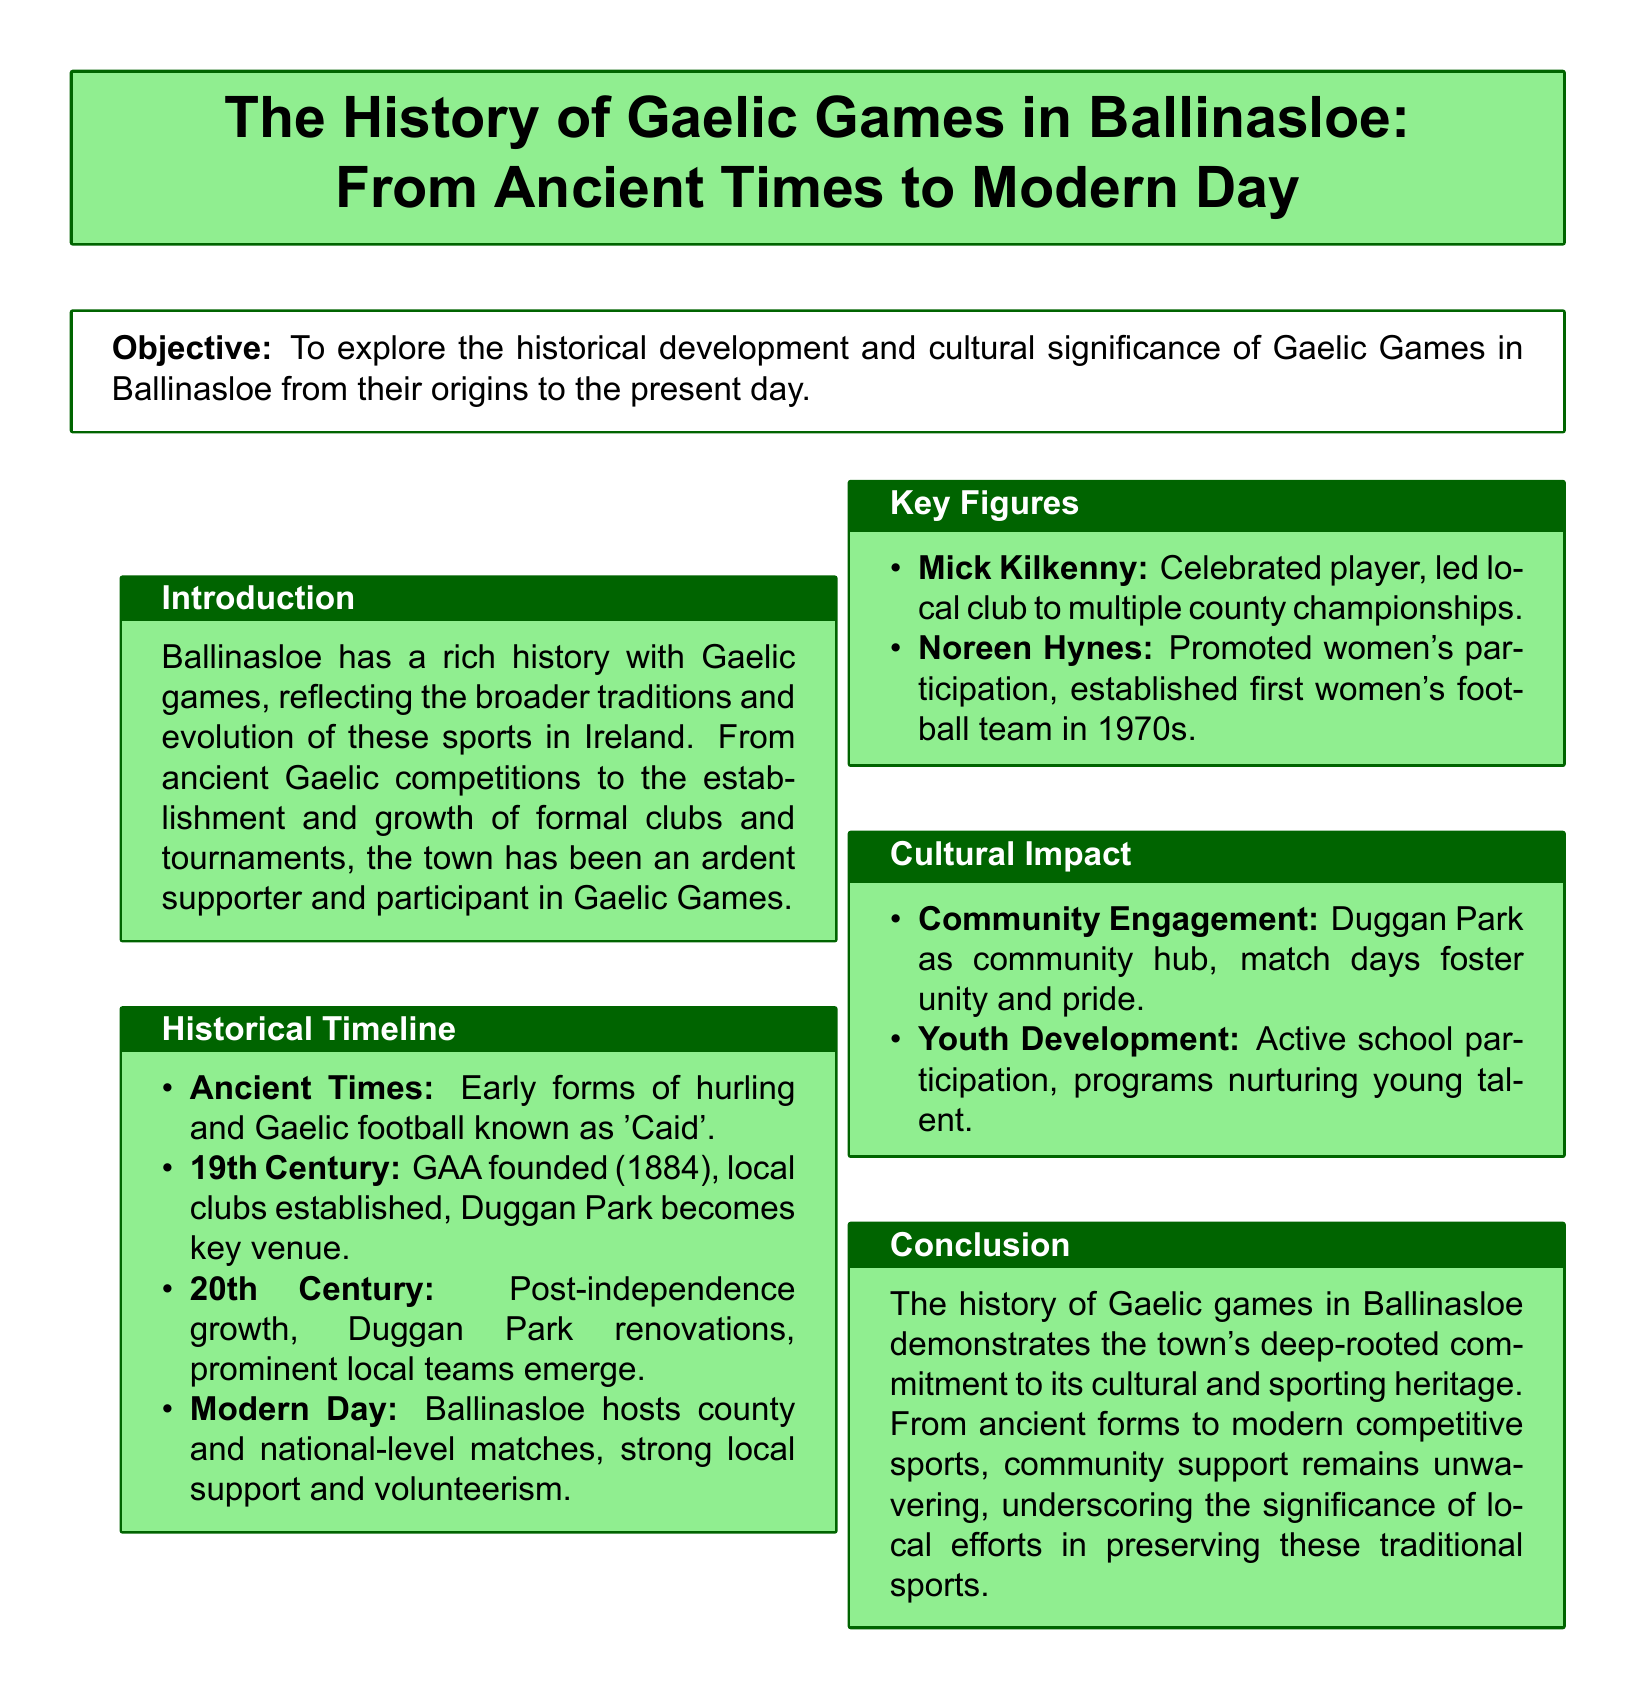What year was the GAA founded? The document states that the GAA was founded in 1884, which is mentioned in the historical timeline.
Answer: 1884 Who established the first women's football team in the 1970s? The document identifies Noreen Hynes as the key figure who promoted women's participation and established the first women's football team.
Answer: Noreen Hynes What role does Duggan Park play in the community? The document highlights Duggan Park as a community hub where match days foster unity and pride, indicating its central role in the community.
Answer: Community hub What is the focus of youth development in Gaelic Games in Ballinasloe? The document mentions active school participation and programs that nurture young talent, emphasizing the importance of youth development.
Answer: Nurturing young talent In which century did the establishment and growth of formal clubs occur? The historical timeline indicates that local clubs were established in the 19th century following the founding of the GAA.
Answer: 19th Century Who led the local club to multiple county championships? According to the key figures section, Mick Kilkenny is recognized as a celebrated player who led the local club to numerous victories.
Answer: Mick Kilkenny What signifies the cultural impact of Gaelic Games in Ballinasloe? The document specifies that community engagement and youth development are significant aspects of the cultural impact of Gaelic Games in Ballinasloe.
Answer: Community engagement and youth development What does the document conclude about Gaelic Games in Ballinasloe? The conclusion summarizes the town's commitment to its cultural and sporting heritage, indicating that local support plays a crucial role in preserving these sports.
Answer: Commitment to cultural and sporting heritage 